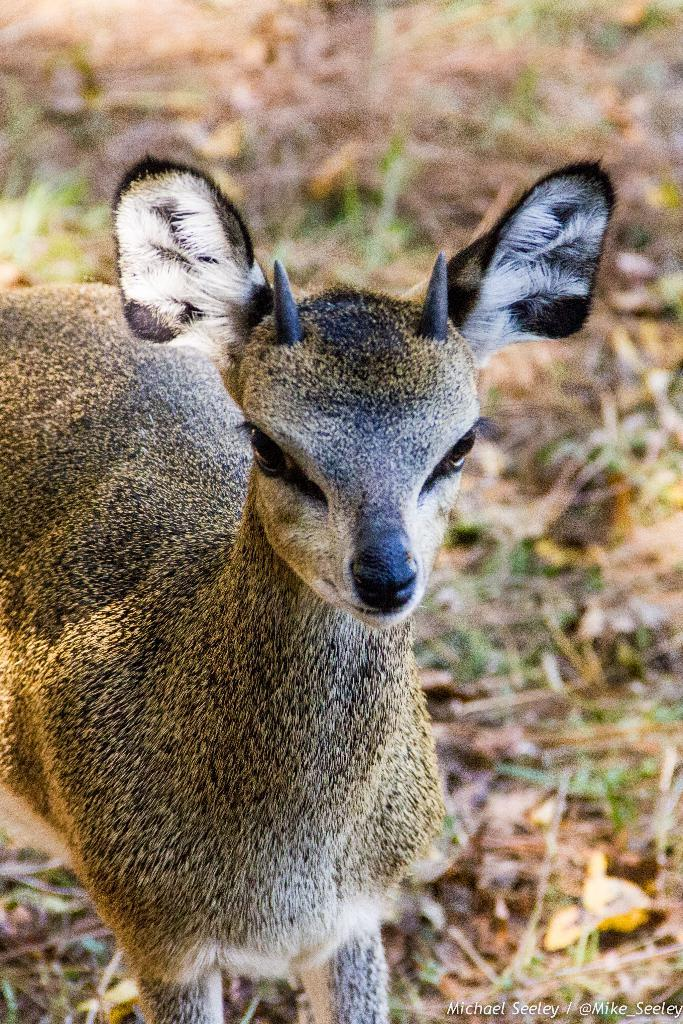What is the main subject in the center of the image? There is an animal in the center of the image. What type of environment is depicted in the image? There is dry grass on the floor in the image. What type of club can be seen in the animal's hand in the image? There is no club present in the image, nor is there any indication that the animal has a hand. 